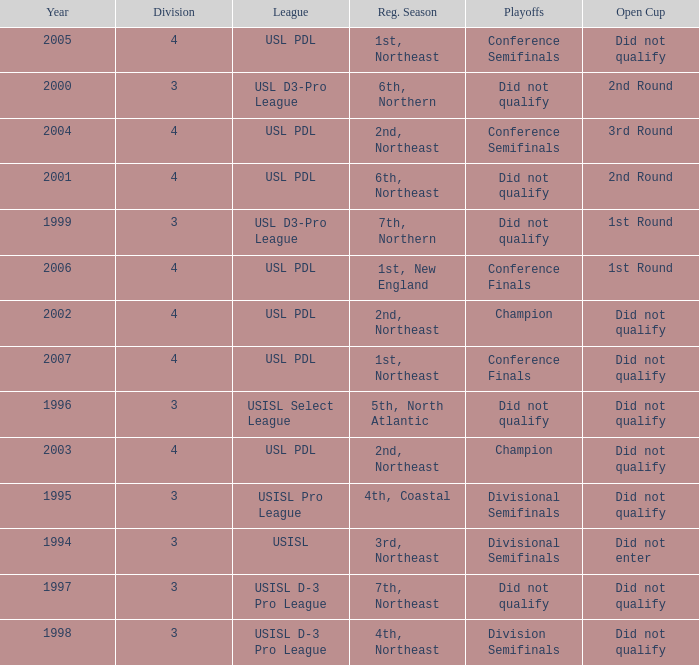Write the full table. {'header': ['Year', 'Division', 'League', 'Reg. Season', 'Playoffs', 'Open Cup'], 'rows': [['2005', '4', 'USL PDL', '1st, Northeast', 'Conference Semifinals', 'Did not qualify'], ['2000', '3', 'USL D3-Pro League', '6th, Northern', 'Did not qualify', '2nd Round'], ['2004', '4', 'USL PDL', '2nd, Northeast', 'Conference Semifinals', '3rd Round'], ['2001', '4', 'USL PDL', '6th, Northeast', 'Did not qualify', '2nd Round'], ['1999', '3', 'USL D3-Pro League', '7th, Northern', 'Did not qualify', '1st Round'], ['2006', '4', 'USL PDL', '1st, New England', 'Conference Finals', '1st Round'], ['2002', '4', 'USL PDL', '2nd, Northeast', 'Champion', 'Did not qualify'], ['2007', '4', 'USL PDL', '1st, Northeast', 'Conference Finals', 'Did not qualify'], ['1996', '3', 'USISL Select League', '5th, North Atlantic', 'Did not qualify', 'Did not qualify'], ['2003', '4', 'USL PDL', '2nd, Northeast', 'Champion', 'Did not qualify'], ['1995', '3', 'USISL Pro League', '4th, Coastal', 'Divisional Semifinals', 'Did not qualify'], ['1994', '3', 'USISL', '3rd, Northeast', 'Divisional Semifinals', 'Did not enter'], ['1997', '3', 'USISL D-3 Pro League', '7th, Northeast', 'Did not qualify', 'Did not qualify'], ['1998', '3', 'USISL D-3 Pro League', '4th, Northeast', 'Division Semifinals', 'Did not qualify']]} Name the number of playoffs for 3rd round 1.0. 